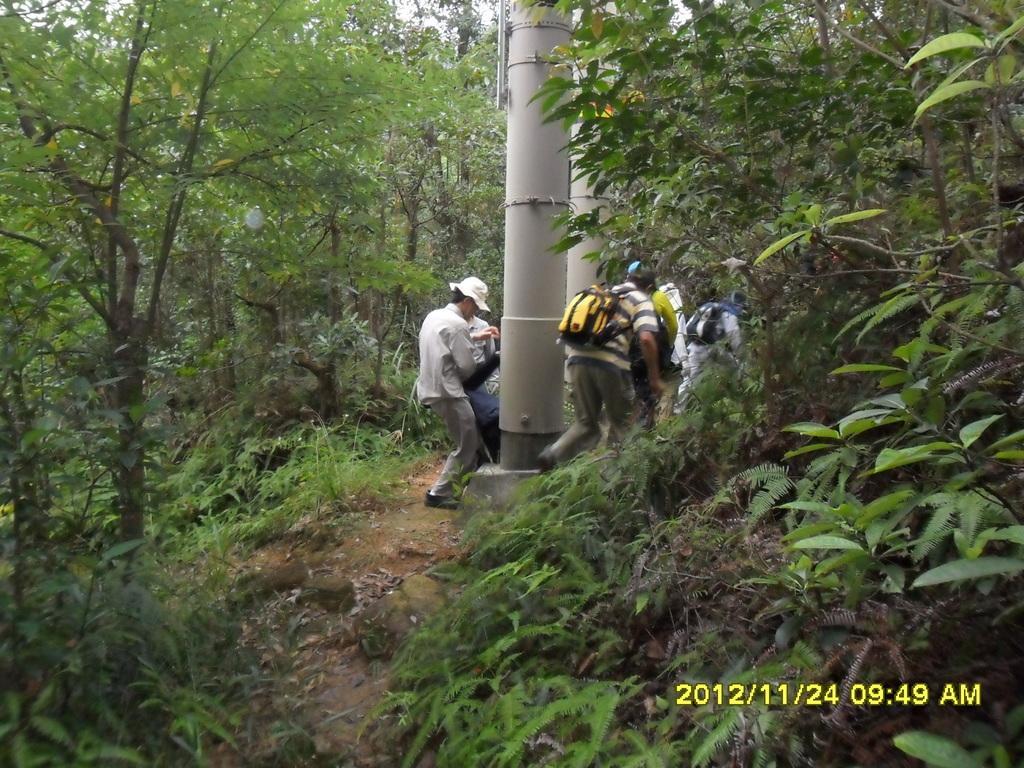Can you describe this image briefly? In this image I can see some people and a pillar like thing on the floor and around there are some trees and plants. 